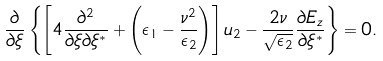<formula> <loc_0><loc_0><loc_500><loc_500>\frac { \partial } { \partial { \xi } } \left \{ \left [ 4 \frac { \partial ^ { 2 } } { \partial \xi \partial \xi ^ { * } } + \left ( \epsilon _ { 1 } - \frac { \nu ^ { 2 } } { \epsilon _ { 2 } } \right ) \right ] u _ { 2 } - \frac { 2 \nu } { \sqrt { \epsilon _ { 2 } } } \frac { \partial { E _ { z } } } { \partial { \xi ^ { * } } } \right \} = 0 .</formula> 